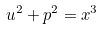Convert formula to latex. <formula><loc_0><loc_0><loc_500><loc_500>u ^ { 2 } + p ^ { 2 } = x ^ { 3 }</formula> 